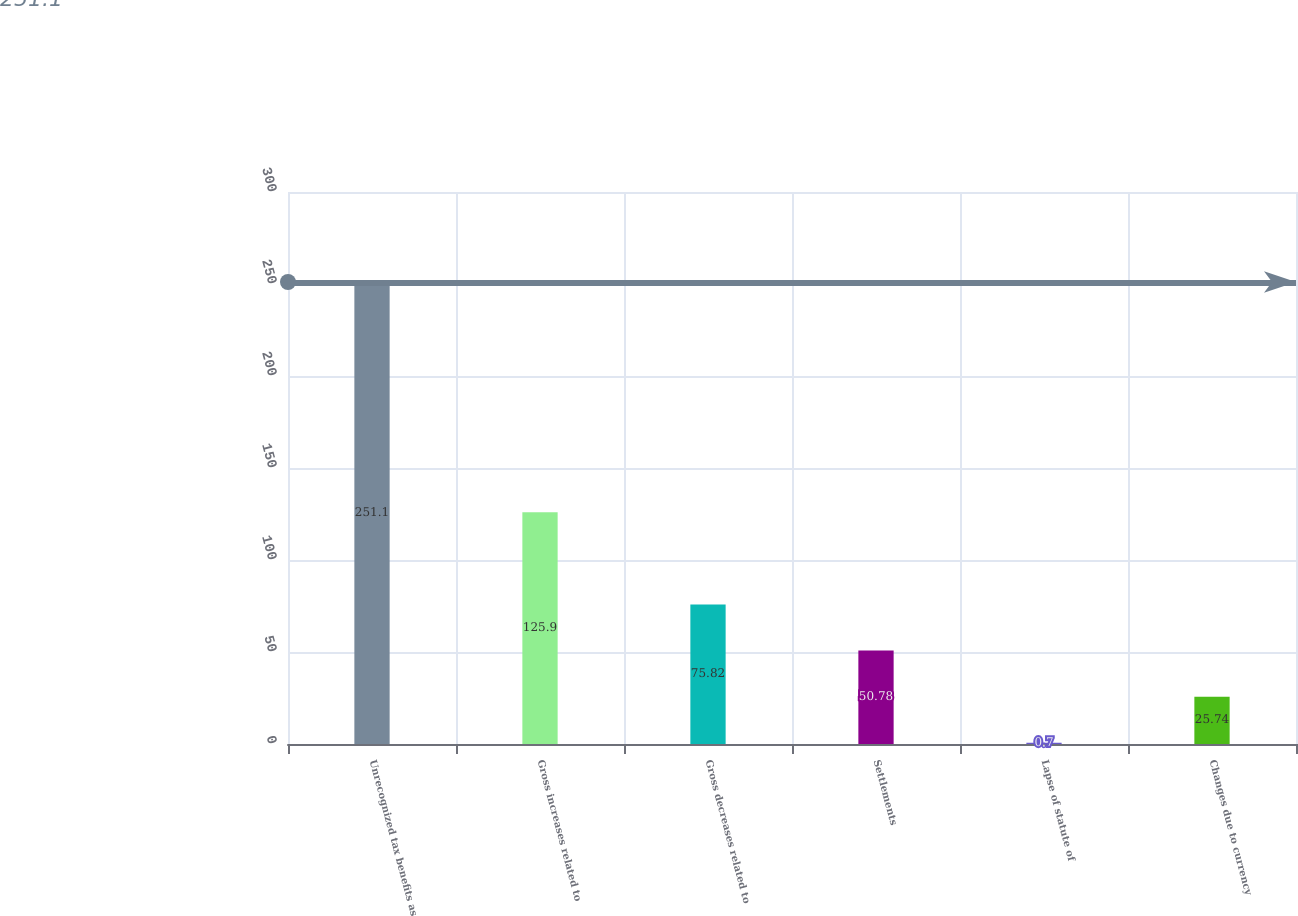Convert chart. <chart><loc_0><loc_0><loc_500><loc_500><bar_chart><fcel>Unrecognized tax benefits as<fcel>Gross increases related to<fcel>Gross decreases related to<fcel>Settlements<fcel>Lapse of statute of<fcel>Changes due to currency<nl><fcel>251.1<fcel>125.9<fcel>75.82<fcel>50.78<fcel>0.7<fcel>25.74<nl></chart> 